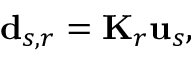Convert formula to latex. <formula><loc_0><loc_0><loc_500><loc_500>d _ { s , r } = K _ { r } u _ { s } ,</formula> 